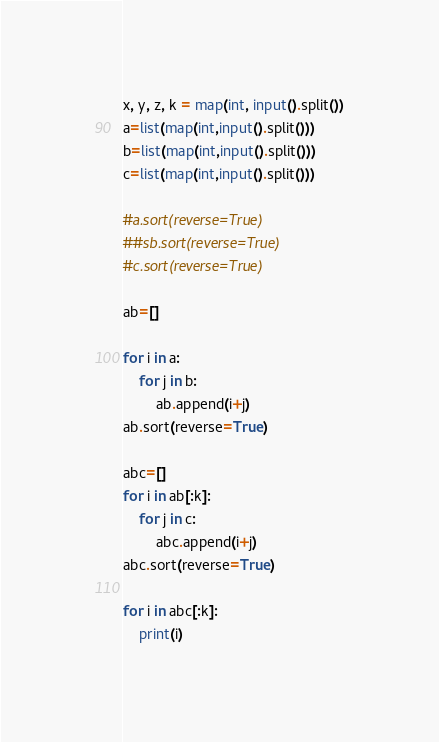<code> <loc_0><loc_0><loc_500><loc_500><_Python_>x, y, z, k = map(int, input().split())
a=list(map(int,input().split()))
b=list(map(int,input().split()))
c=list(map(int,input().split()))

#a.sort(reverse=True)
##sb.sort(reverse=True)
#c.sort(reverse=True)            

ab=[]

for i in a:
    for j in b:
        ab.append(i+j)
ab.sort(reverse=True)

abc=[]
for i in ab[:k]:
    for j in c:
        abc.append(i+j)
abc.sort(reverse=True)

for i in abc[:k]:
    print(i)</code> 